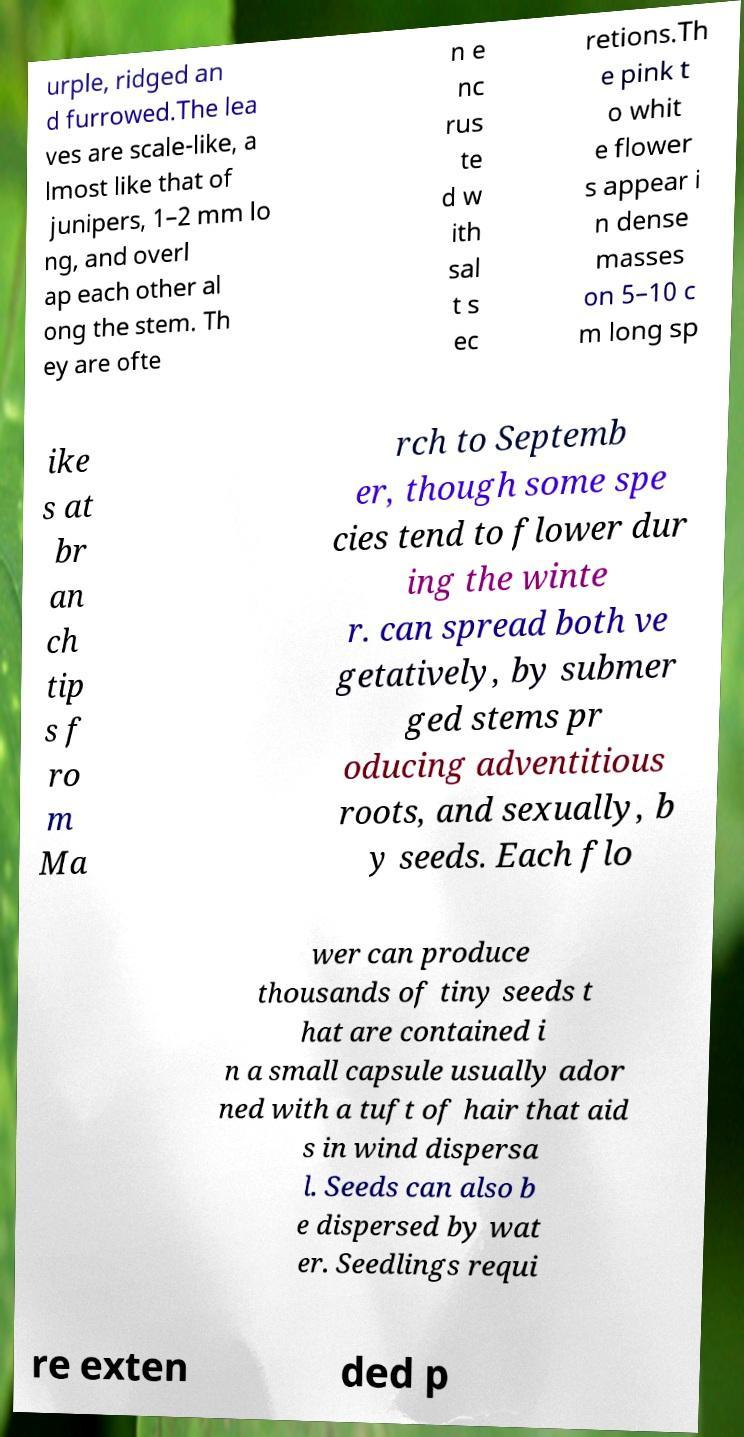Please read and relay the text visible in this image. What does it say? urple, ridged an d furrowed.The lea ves are scale-like, a lmost like that of junipers, 1–2 mm lo ng, and overl ap each other al ong the stem. Th ey are ofte n e nc rus te d w ith sal t s ec retions.Th e pink t o whit e flower s appear i n dense masses on 5–10 c m long sp ike s at br an ch tip s f ro m Ma rch to Septemb er, though some spe cies tend to flower dur ing the winte r. can spread both ve getatively, by submer ged stems pr oducing adventitious roots, and sexually, b y seeds. Each flo wer can produce thousands of tiny seeds t hat are contained i n a small capsule usually ador ned with a tuft of hair that aid s in wind dispersa l. Seeds can also b e dispersed by wat er. Seedlings requi re exten ded p 